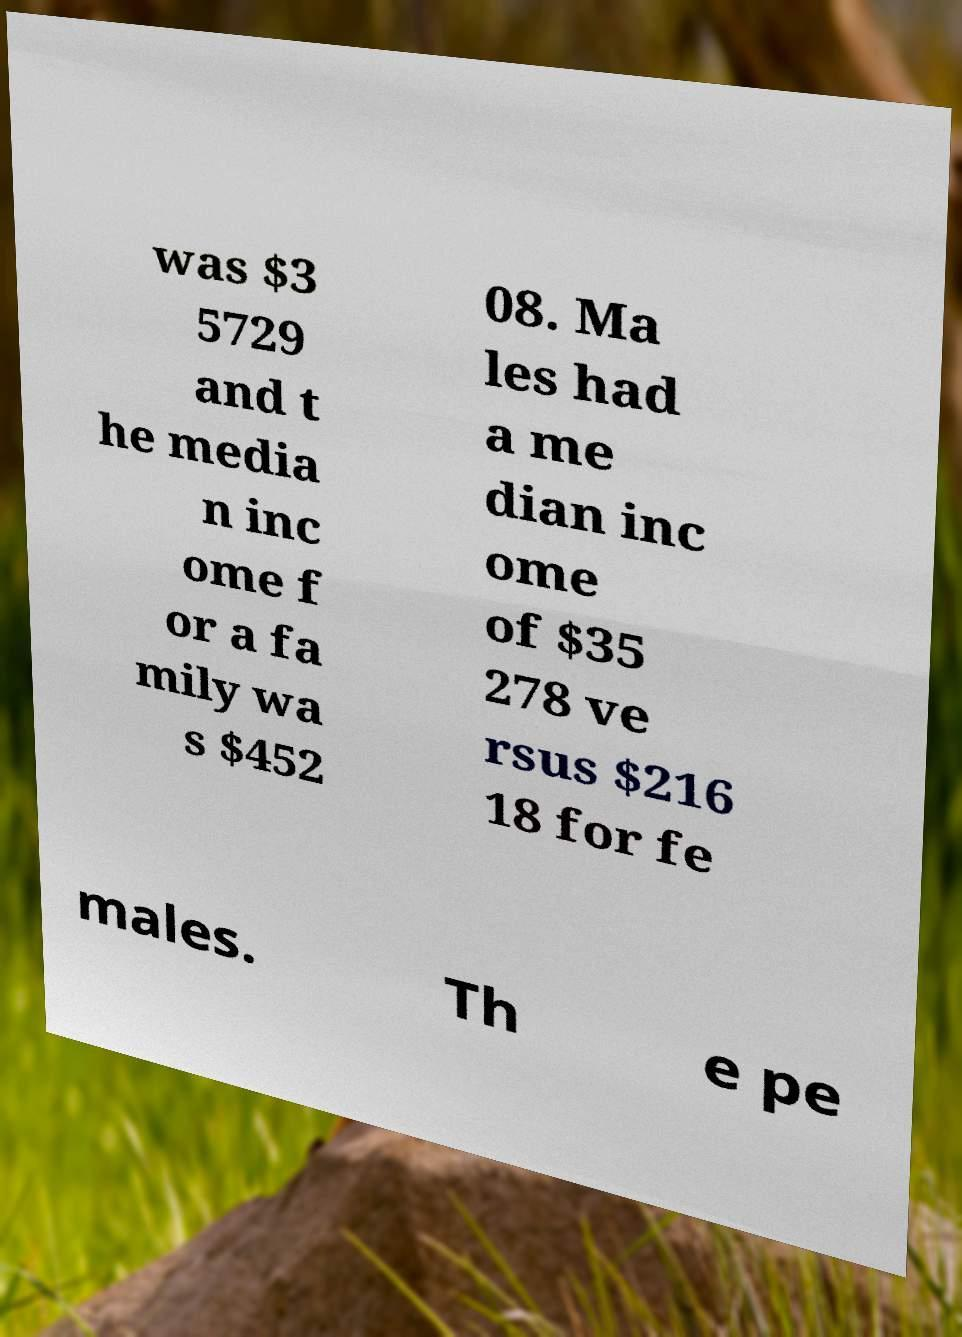For documentation purposes, I need the text within this image transcribed. Could you provide that? was $3 5729 and t he media n inc ome f or a fa mily wa s $452 08. Ma les had a me dian inc ome of $35 278 ve rsus $216 18 for fe males. Th e pe 